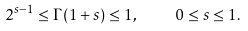<formula> <loc_0><loc_0><loc_500><loc_500>2 ^ { s - 1 } \leq \Gamma ( 1 + s ) \leq 1 , \quad 0 \leq s \leq 1 .</formula> 